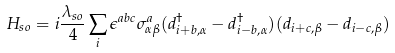<formula> <loc_0><loc_0><loc_500><loc_500>H _ { s o } = i \frac { \lambda _ { s o } } { 4 } \sum _ { i } \epsilon ^ { a b c } \sigma ^ { a } _ { \alpha \beta } ( d ^ { \dagger } _ { i + b , \alpha } - d ^ { \dagger } _ { i - b , \alpha } ) ( d _ { i + c , \beta } - d _ { i - c , \beta } )</formula> 